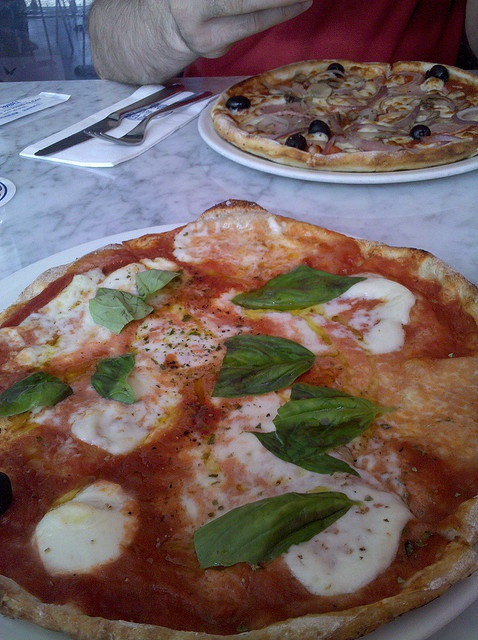Describe the objects in this image and their specific colors. I can see pizza in navy, maroon, darkgray, gray, and olive tones, pizza in navy, gray, maroon, and darkgray tones, people in navy, maroon, black, and gray tones, knife in navy, black, gray, and darkblue tones, and fork in navy, gray, black, and purple tones in this image. 